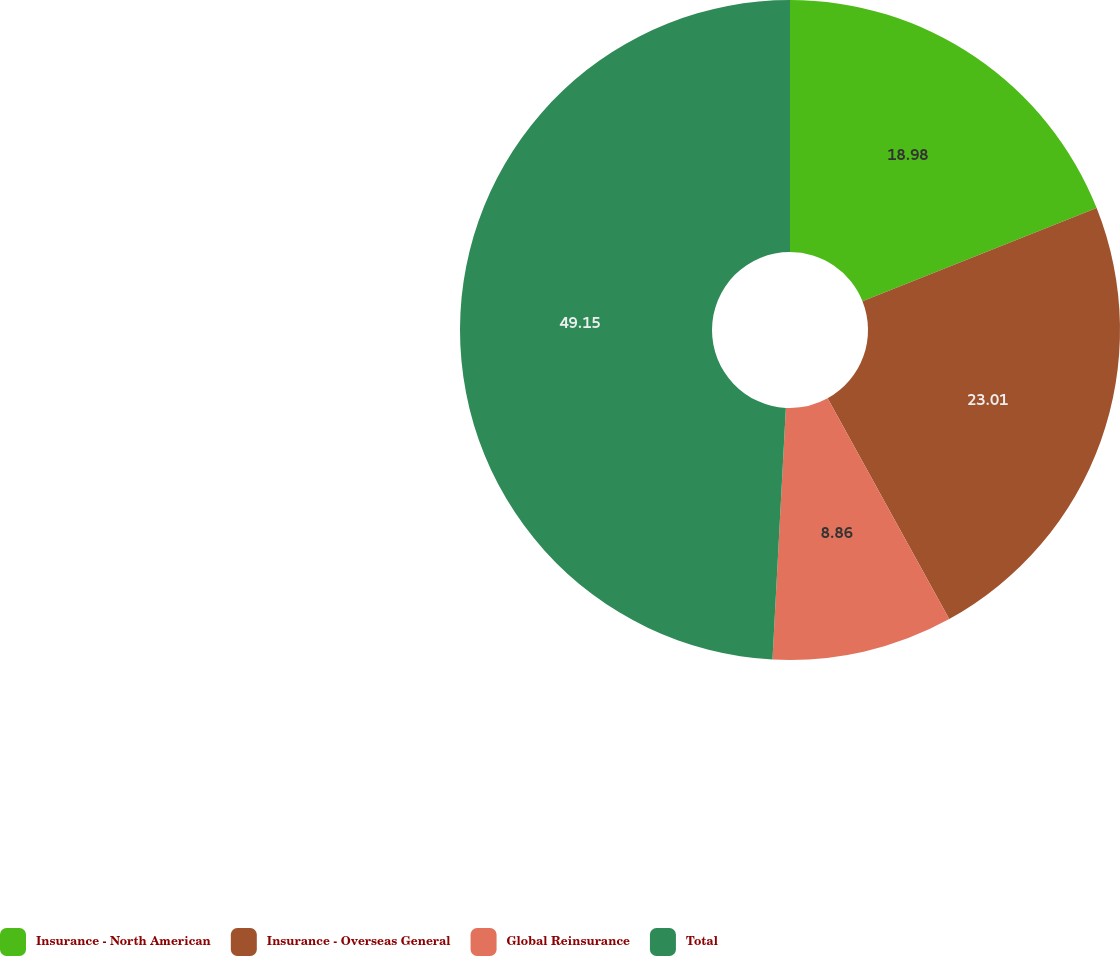Convert chart to OTSL. <chart><loc_0><loc_0><loc_500><loc_500><pie_chart><fcel>Insurance - North American<fcel>Insurance - Overseas General<fcel>Global Reinsurance<fcel>Total<nl><fcel>18.98%<fcel>23.01%<fcel>8.86%<fcel>49.16%<nl></chart> 